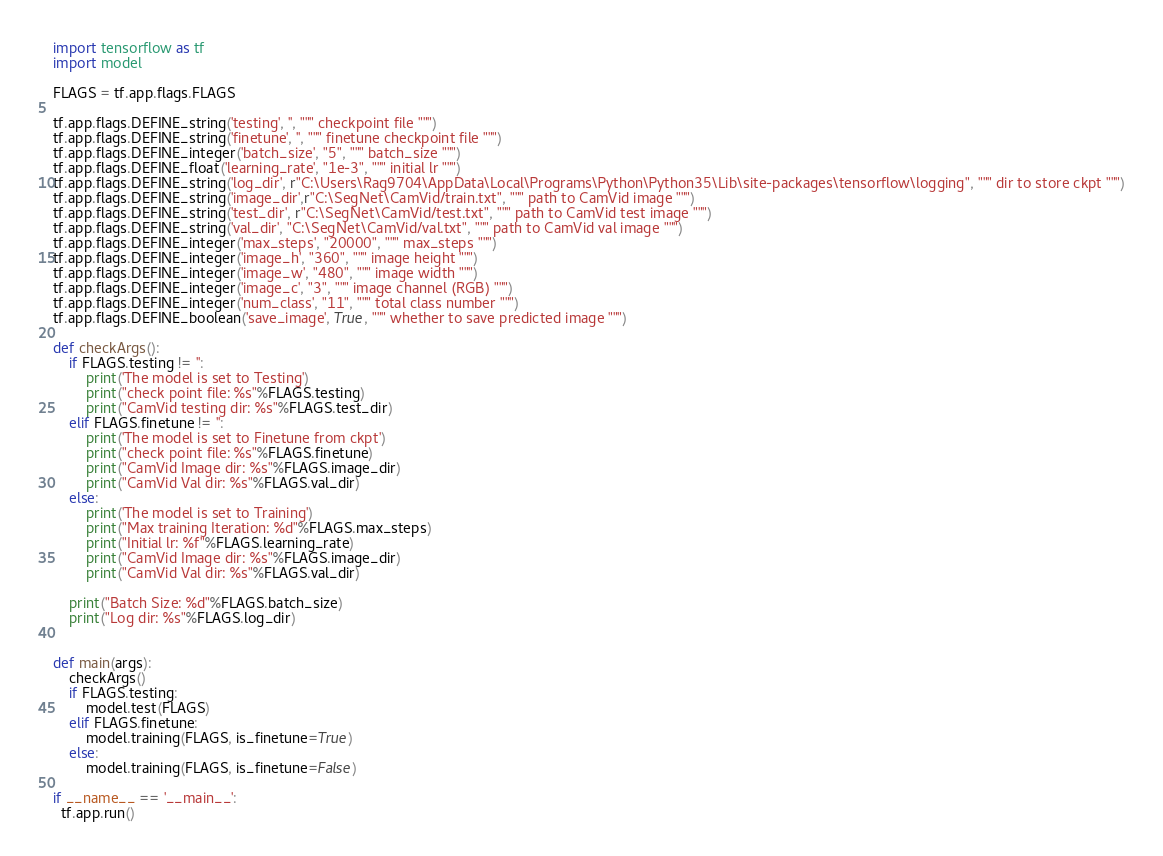Convert code to text. <code><loc_0><loc_0><loc_500><loc_500><_Python_>import tensorflow as tf
import model

FLAGS = tf.app.flags.FLAGS

tf.app.flags.DEFINE_string('testing', '', """ checkpoint file """)
tf.app.flags.DEFINE_string('finetune', '', """ finetune checkpoint file """)
tf.app.flags.DEFINE_integer('batch_size', "5", """ batch_size """)
tf.app.flags.DEFINE_float('learning_rate', "1e-3", """ initial lr """)
tf.app.flags.DEFINE_string('log_dir', r"C:\Users\Rag9704\AppData\Local\Programs\Python\Python35\Lib\site-packages\tensorflow\logging", """ dir to store ckpt """)
tf.app.flags.DEFINE_string('image_dir',r"C:\SegNet\CamVid/train.txt", """ path to CamVid image """)
tf.app.flags.DEFINE_string('test_dir', r"C:\SegNet\CamVid/test.txt", """ path to CamVid test image """)
tf.app.flags.DEFINE_string('val_dir', "C:\SegNet\CamVid/val.txt", """ path to CamVid val image """)
tf.app.flags.DEFINE_integer('max_steps', "20000", """ max_steps """)
tf.app.flags.DEFINE_integer('image_h', "360", """ image height """)
tf.app.flags.DEFINE_integer('image_w', "480", """ image width """)
tf.app.flags.DEFINE_integer('image_c', "3", """ image channel (RGB) """)
tf.app.flags.DEFINE_integer('num_class', "11", """ total class number """)
tf.app.flags.DEFINE_boolean('save_image', True, """ whether to save predicted image """)

def checkArgs():
    if FLAGS.testing != '':
        print('The model is set to Testing')
        print("check point file: %s"%FLAGS.testing)
        print("CamVid testing dir: %s"%FLAGS.test_dir)
    elif FLAGS.finetune != '':
        print('The model is set to Finetune from ckpt')
        print("check point file: %s"%FLAGS.finetune)
        print("CamVid Image dir: %s"%FLAGS.image_dir)
        print("CamVid Val dir: %s"%FLAGS.val_dir)
    else:
        print('The model is set to Training')
        print("Max training Iteration: %d"%FLAGS.max_steps)
        print("Initial lr: %f"%FLAGS.learning_rate)
        print("CamVid Image dir: %s"%FLAGS.image_dir)
        print("CamVid Val dir: %s"%FLAGS.val_dir)

    print("Batch Size: %d"%FLAGS.batch_size)
    print("Log dir: %s"%FLAGS.log_dir)


def main(args):
    checkArgs()
    if FLAGS.testing:
        model.test(FLAGS)
    elif FLAGS.finetune:
        model.training(FLAGS, is_finetune=True)
    else:
        model.training(FLAGS, is_finetune=False)

if __name__ == '__main__':
  tf.app.run()
</code> 